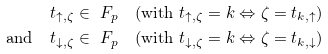Convert formula to latex. <formula><loc_0><loc_0><loc_500><loc_500>& t _ { \uparrow , \zeta } \in \ F _ { p } \quad \text {(with } t _ { \uparrow , \zeta } = k \Leftrightarrow \zeta = t _ { k , \uparrow } \text {)} \\ \text {and} \quad & t _ { \downarrow , \zeta } \in \ F _ { p } \quad \text {(with } t _ { \downarrow , \zeta } = k \Leftrightarrow \zeta = t _ { k , \downarrow } \text {)}</formula> 